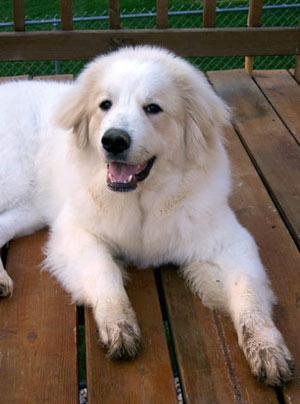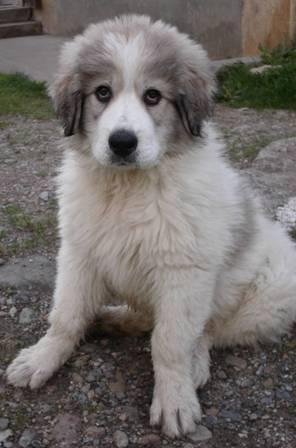The first image is the image on the left, the second image is the image on the right. Considering the images on both sides, is "Left image shows two dogs posed together outdoors." valid? Answer yes or no. No. 